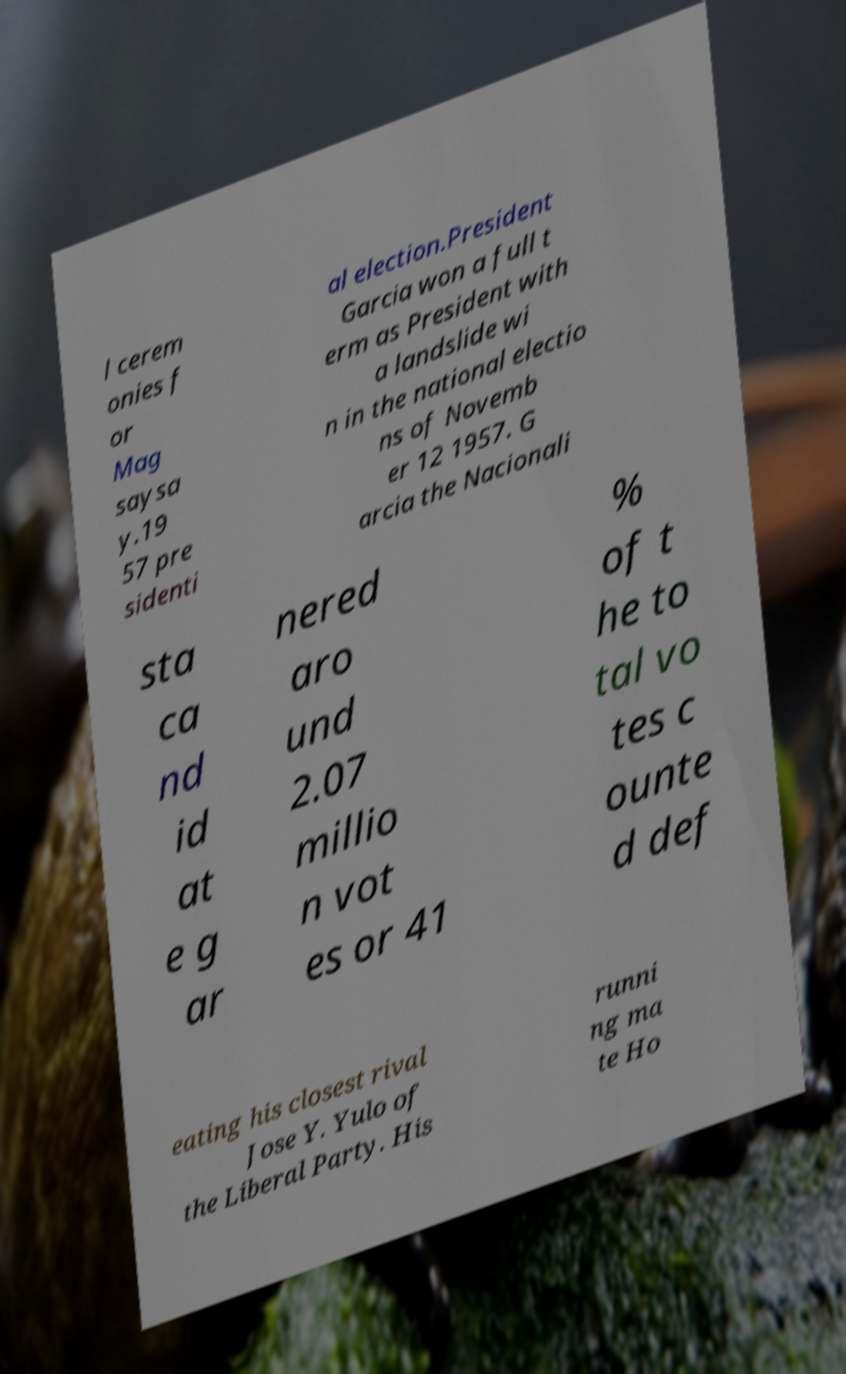Could you extract and type out the text from this image? l cerem onies f or Mag saysa y.19 57 pre sidenti al election.President Garcia won a full t erm as President with a landslide wi n in the national electio ns of Novemb er 12 1957. G arcia the Nacionali sta ca nd id at e g ar nered aro und 2.07 millio n vot es or 41 % of t he to tal vo tes c ounte d def eating his closest rival Jose Y. Yulo of the Liberal Party. His runni ng ma te Ho 